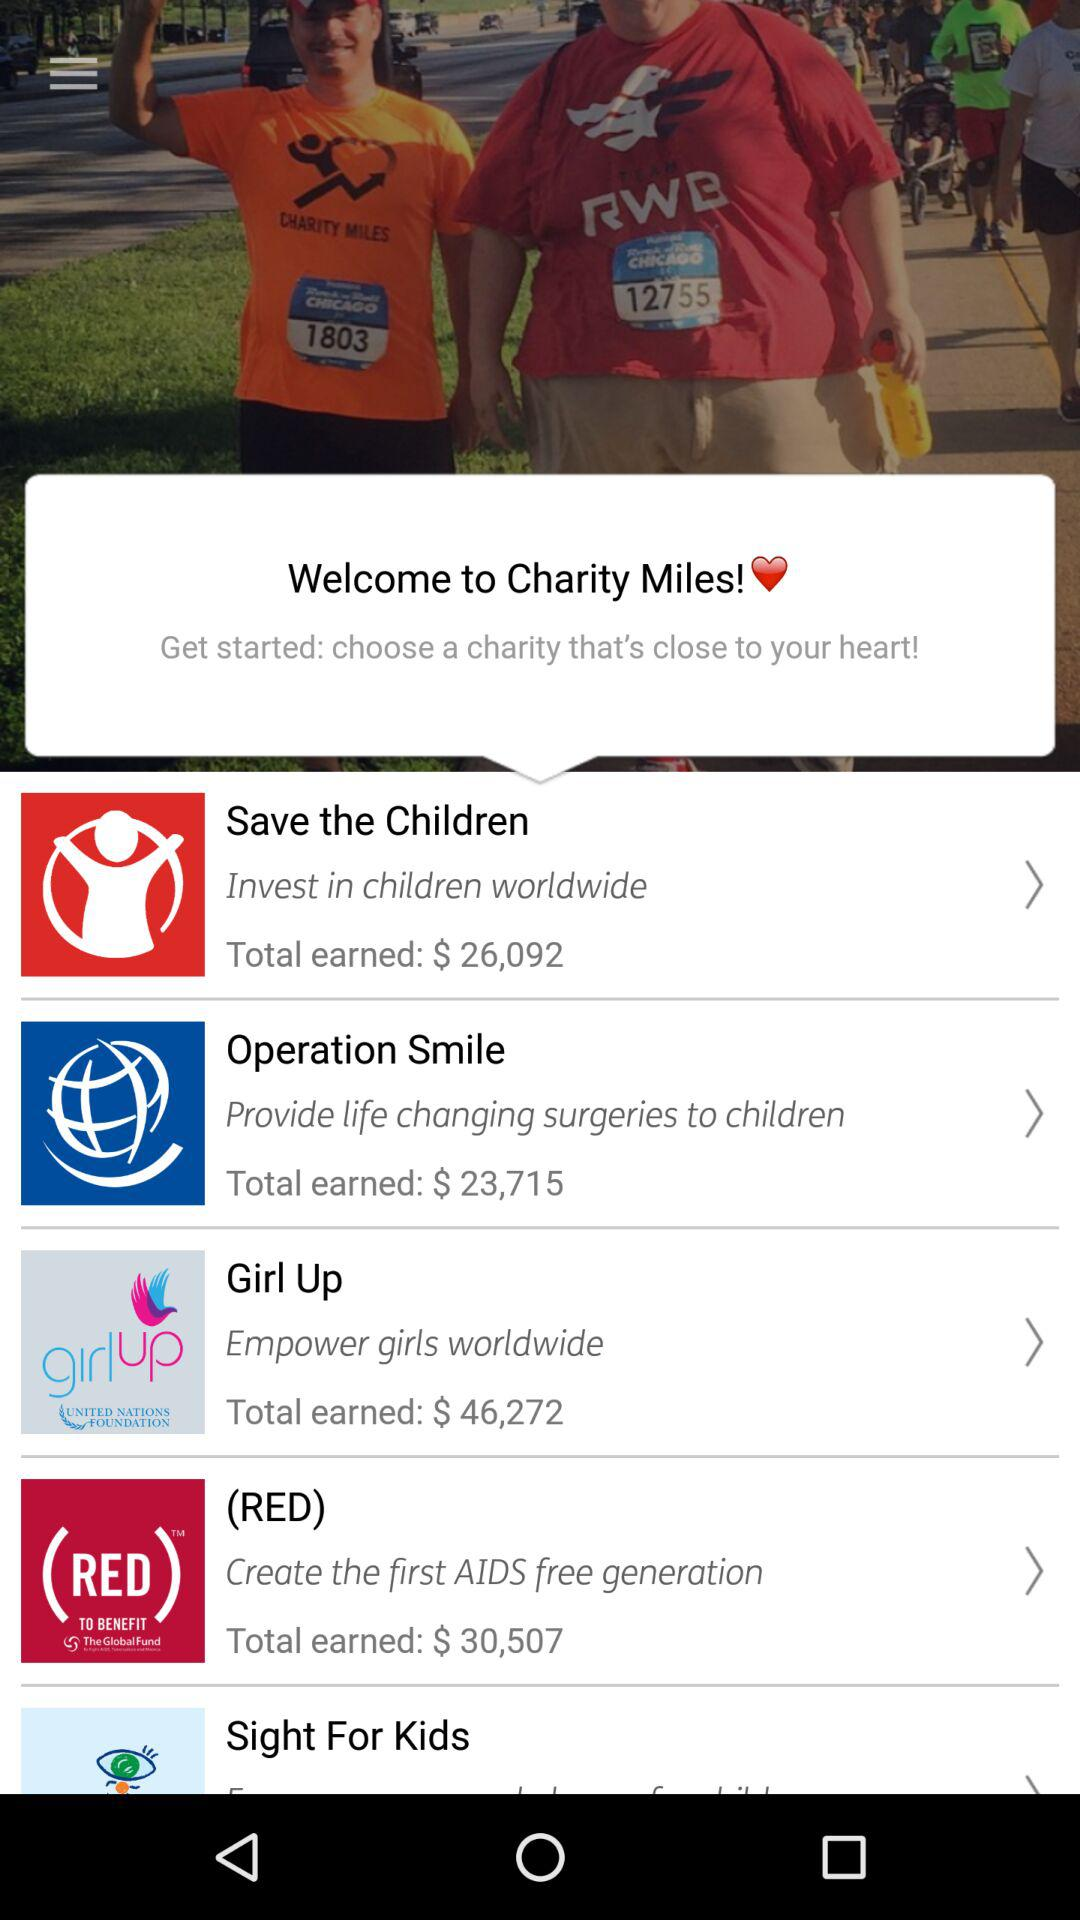Which organizations are displayed on the screen? The displayed organizations are "Save the Children", "Operation Smile", "Girl Up", "(RED)" and "Sight For Kids". 